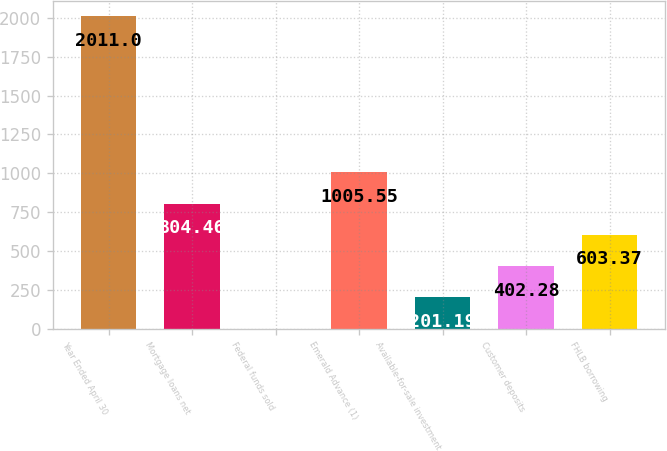Convert chart to OTSL. <chart><loc_0><loc_0><loc_500><loc_500><bar_chart><fcel>Year Ended April 30<fcel>Mortgage loans net<fcel>Federal funds sold<fcel>Emerald Advance (1)<fcel>Available-for-sale investment<fcel>Customer deposits<fcel>FHLB borrowing<nl><fcel>2011<fcel>804.46<fcel>0.1<fcel>1005.55<fcel>201.19<fcel>402.28<fcel>603.37<nl></chart> 